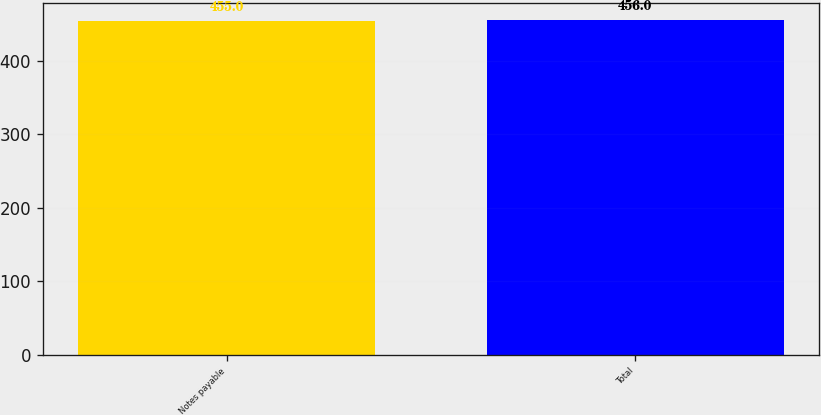Convert chart. <chart><loc_0><loc_0><loc_500><loc_500><bar_chart><fcel>Notes payable<fcel>Total<nl><fcel>455<fcel>456<nl></chart> 